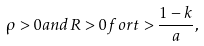Convert formula to latex. <formula><loc_0><loc_0><loc_500><loc_500>\rho > 0 a n d R > 0 f o r t > \frac { 1 - k } { a } ,</formula> 